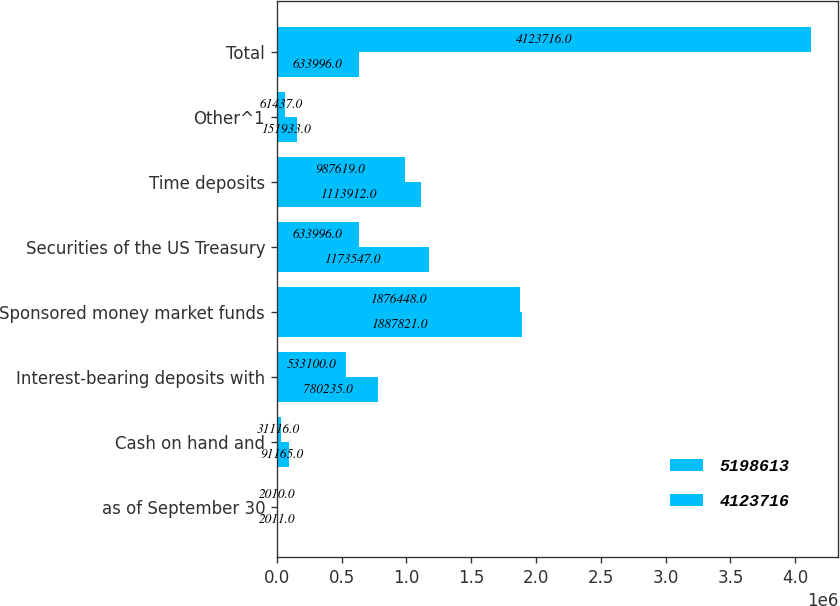<chart> <loc_0><loc_0><loc_500><loc_500><stacked_bar_chart><ecel><fcel>as of September 30<fcel>Cash on hand and<fcel>Interest-bearing deposits with<fcel>Sponsored money market funds<fcel>Securities of the US Treasury<fcel>Time deposits<fcel>Other^1<fcel>Total<nl><fcel>5.19861e+06<fcel>2011<fcel>91165<fcel>780235<fcel>1.88782e+06<fcel>1.17355e+06<fcel>1.11391e+06<fcel>151933<fcel>633996<nl><fcel>4.12372e+06<fcel>2010<fcel>31116<fcel>533100<fcel>1.87645e+06<fcel>633996<fcel>987619<fcel>61437<fcel>4.12372e+06<nl></chart> 